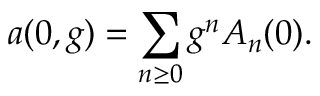<formula> <loc_0><loc_0><loc_500><loc_500>a ( 0 , g ) = \sum _ { n \geq 0 } g ^ { n } A _ { n } ( 0 ) .</formula> 